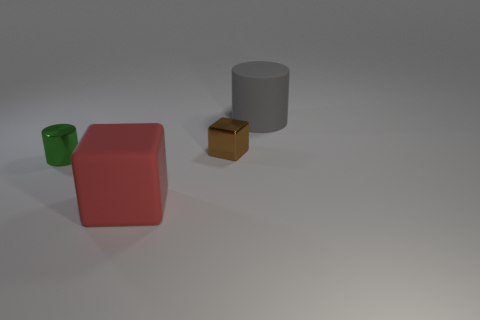Does the rubber cylinder have the same size as the brown thing?
Provide a succinct answer. No. What number of things are gray rubber cylinders or big things that are behind the rubber cube?
Ensure brevity in your answer.  1. What material is the cylinder that is the same size as the red cube?
Keep it short and to the point. Rubber. What is the object that is to the right of the small green thing and in front of the small brown metal object made of?
Provide a succinct answer. Rubber. Is there a block that is in front of the shiny object on the left side of the tiny metallic cube?
Your response must be concise. Yes. What size is the object that is both in front of the tiny block and to the right of the green metallic cylinder?
Offer a terse response. Large. What number of yellow things are matte blocks or metallic cubes?
Make the answer very short. 0. There is a matte thing that is the same size as the gray matte cylinder; what is its shape?
Make the answer very short. Cube. What number of other objects are there of the same color as the metallic cylinder?
Give a very brief answer. 0. How big is the cylinder that is on the left side of the big object on the left side of the brown block?
Offer a terse response. Small. 